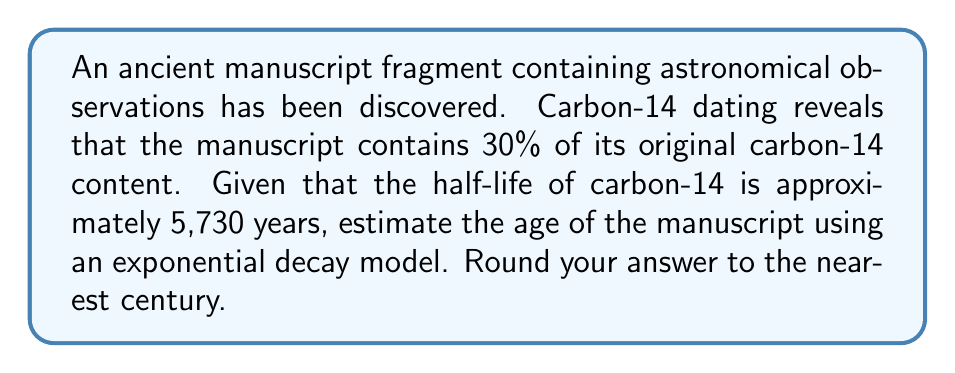Show me your answer to this math problem. Let's approach this step-by-step using the exponential decay model:

1) The general form of the exponential decay equation is:
   $$ A(t) = A_0 e^{-kt} $$
   where $A(t)$ is the amount at time $t$, $A_0$ is the initial amount, $k$ is the decay constant, and $t$ is time.

2) We know that 30% of the original carbon-14 remains, so:
   $$ \frac{A(t)}{A_0} = 0.30 $$

3) The half-life $t_{1/2}$ is 5,730 years. We can use this to find the decay constant $k$:
   $$ k = \frac{\ln(2)}{t_{1/2}} = \frac{\ln(2)}{5730} \approx 0.000121 $$

4) Now we can set up our equation:
   $$ 0.30 = e^{-0.000121t} $$

5) Taking the natural log of both sides:
   $$ \ln(0.30) = -0.000121t $$

6) Solving for $t$:
   $$ t = \frac{\ln(0.30)}{-0.000121} \approx 9967.8 \text{ years} $$

7) Rounding to the nearest century:
   $$ 9967.8 \text{ years} \approx 10,000 \text{ years} $$
Answer: 10,000 years 